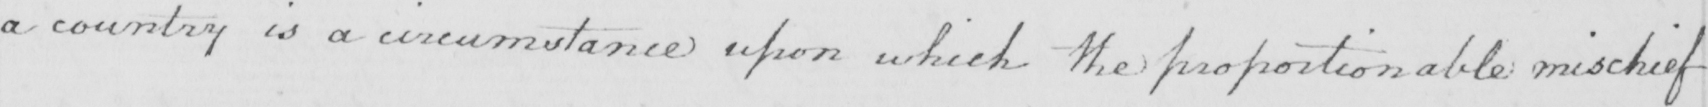What is written in this line of handwriting? a country is a circumstance upon which the proportionable mischief 